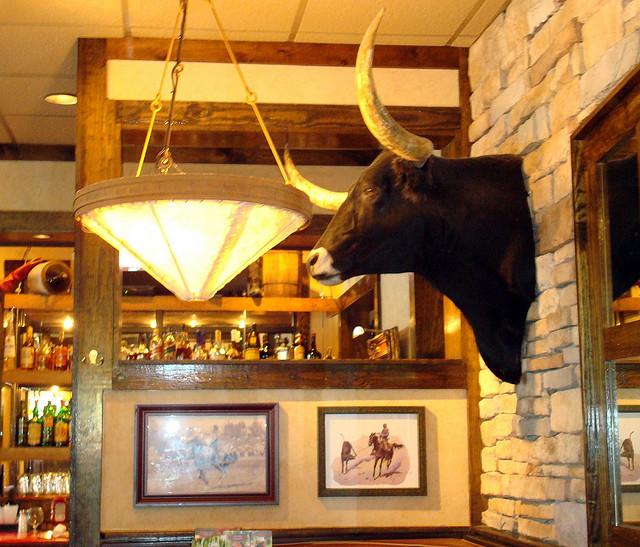Is there a lot of alcohol?
Be succinct. Yes. What does the bull have on its head?
Quick response, please. Horns. Was this photo taken in a home?
Be succinct. No. 